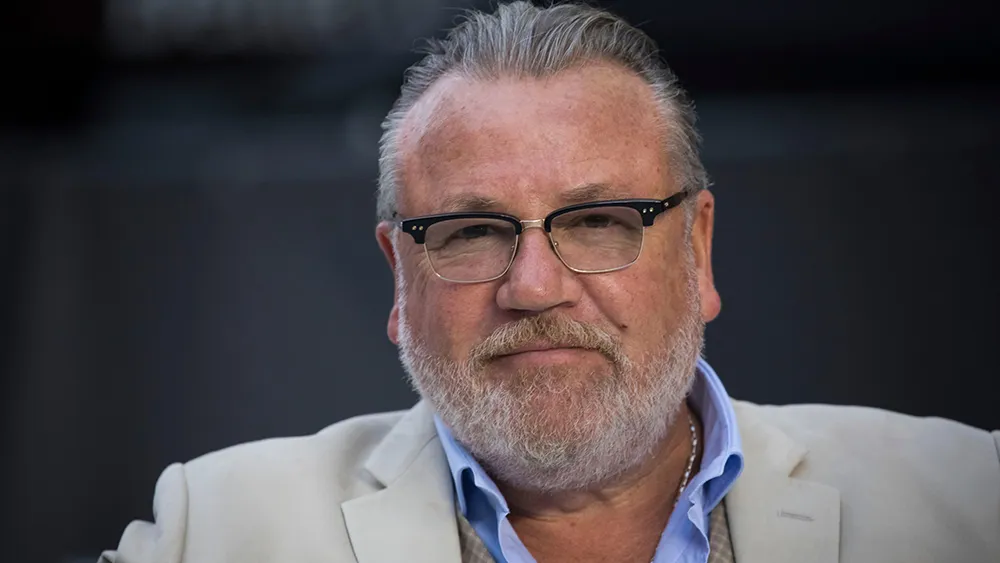How does the choice of attire influence our perception of the individual in the photo? The man's choice of a crisp white blazer over a blue shirt conveys a sense of professionalism and sophistication. This attire often suggests a person of significance, possibly in a business or creative field, and influences us to view him as someone respectable and well-established. 